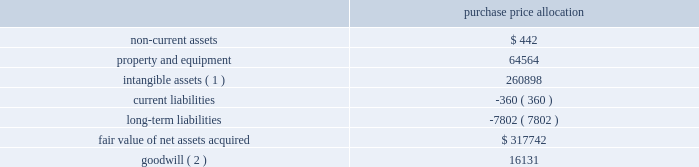American tower corporation and subsidiaries notes to consolidated financial statements u.s .
Acquisitions 2014during the year ended december 31 , 2010 , the company acquired 548 towers through multiple acquisitions in the united states for an aggregate purchase price of $ 329.3 million and contingent consideration of approximately $ 4.6 million .
The acquisition of these towers is consistent with the company 2019s strategy to expand in selected geographic areas and have been accounted for as business combinations .
The table summarizes the preliminary allocation of the aggregate purchase consideration paid and the amounts of assets acquired and liabilities assumed based on the estimated fair value of the acquired assets and assumed liabilities at the date of acquisition ( in thousands ) : purchase price allocation .
( 1 ) consists of customer relationships of approximately $ 205.4 million and network location intangibles of approximately $ 55.5 million .
The customer relationships and network location intangibles are being amortized on a straight-line basis over a period of 20 years .
( 2 ) goodwill is expected to be deductible for income tax purposes .
The goodwill was allocated to the domestic rental and management segment .
The allocation of the purchase price will be finalized upon completion of analyses of the fair value of the assets acquired and liabilities assumed .
South africa acquisition 2014on november 4 , 2010 , the company entered into a definitive agreement with cell c ( pty ) limited to purchase up to approximately 1400 existing towers , and up to 1800 additional towers that either are under construction or will be constructed , for an aggregate purchase price of up to approximately $ 430 million .
The company anticipates closing the purchase of up to 1400 existing towers during 2011 , subject to customary closing conditions .
Other transactions coltel transaction 2014on september 3 , 2010 , the company entered into a definitive agreement to purchase the exclusive use rights for towers in colombia from colombia telecomunicaciones s.a .
E.s.p .
( 201ccoltel 201d ) until 2023 , when ownership of the towers will transfer to the company at no additional cost .
Pursuant to that agreement , the company completed the purchase of exclusive use rights for 508 towers for an aggregate purchase price of $ 86.8 million during the year ended december 31 , 2010 .
The company expects to complete the purchase of the exclusive use rights for an additional 180 towers by the end of 2011 , subject to customary closing conditions .
The transaction has been accounted for as a capital lease , with the aggregated purchase price being allocated to property and equipment and non-current assets .
Joint venture with mtn group 2014on december 6 , 2010 , the company entered into a definitive agreement with mtn group limited ( 201cmtn group 201d ) to establish a joint venture in ghana ( 201ctowerco ghana 201d ) .
Towerco ghana , which will be managed by the company , will be owned by a holding company of which a wholly owned american tower subsidiary will hold a 51% ( 51 % ) share and a wholly owned mtn group subsidiary ( 201cmtn ghana 201d ) will hold a 49% ( 49 % ) share .
The transaction involves the sale of up to 1876 of mtn ghana 2019s existing sites to .
Of the total fair value of net assets acquired what was the percent applicable to the equipment? 
Computations: (64564 / 317742)
Answer: 0.2032. American tower corporation and subsidiaries notes to consolidated financial statements u.s .
Acquisitions 2014during the year ended december 31 , 2010 , the company acquired 548 towers through multiple acquisitions in the united states for an aggregate purchase price of $ 329.3 million and contingent consideration of approximately $ 4.6 million .
The acquisition of these towers is consistent with the company 2019s strategy to expand in selected geographic areas and have been accounted for as business combinations .
The table summarizes the preliminary allocation of the aggregate purchase consideration paid and the amounts of assets acquired and liabilities assumed based on the estimated fair value of the acquired assets and assumed liabilities at the date of acquisition ( in thousands ) : purchase price allocation .
( 1 ) consists of customer relationships of approximately $ 205.4 million and network location intangibles of approximately $ 55.5 million .
The customer relationships and network location intangibles are being amortized on a straight-line basis over a period of 20 years .
( 2 ) goodwill is expected to be deductible for income tax purposes .
The goodwill was allocated to the domestic rental and management segment .
The allocation of the purchase price will be finalized upon completion of analyses of the fair value of the assets acquired and liabilities assumed .
South africa acquisition 2014on november 4 , 2010 , the company entered into a definitive agreement with cell c ( pty ) limited to purchase up to approximately 1400 existing towers , and up to 1800 additional towers that either are under construction or will be constructed , for an aggregate purchase price of up to approximately $ 430 million .
The company anticipates closing the purchase of up to 1400 existing towers during 2011 , subject to customary closing conditions .
Other transactions coltel transaction 2014on september 3 , 2010 , the company entered into a definitive agreement to purchase the exclusive use rights for towers in colombia from colombia telecomunicaciones s.a .
E.s.p .
( 201ccoltel 201d ) until 2023 , when ownership of the towers will transfer to the company at no additional cost .
Pursuant to that agreement , the company completed the purchase of exclusive use rights for 508 towers for an aggregate purchase price of $ 86.8 million during the year ended december 31 , 2010 .
The company expects to complete the purchase of the exclusive use rights for an additional 180 towers by the end of 2011 , subject to customary closing conditions .
The transaction has been accounted for as a capital lease , with the aggregated purchase price being allocated to property and equipment and non-current assets .
Joint venture with mtn group 2014on december 6 , 2010 , the company entered into a definitive agreement with mtn group limited ( 201cmtn group 201d ) to establish a joint venture in ghana ( 201ctowerco ghana 201d ) .
Towerco ghana , which will be managed by the company , will be owned by a holding company of which a wholly owned american tower subsidiary will hold a 51% ( 51 % ) share and a wholly owned mtn group subsidiary ( 201cmtn ghana 201d ) will hold a 49% ( 49 % ) share .
The transaction involves the sale of up to 1876 of mtn ghana 2019s existing sites to .
Based on the agreement what was the average price completed the purchase of exclusive use rights to the towers in 2010 in millions? 
Computations: (86.8 / 508)
Answer: 0.17087. American tower corporation and subsidiaries notes to consolidated financial statements u.s .
Acquisitions 2014during the year ended december 31 , 2010 , the company acquired 548 towers through multiple acquisitions in the united states for an aggregate purchase price of $ 329.3 million and contingent consideration of approximately $ 4.6 million .
The acquisition of these towers is consistent with the company 2019s strategy to expand in selected geographic areas and have been accounted for as business combinations .
The table summarizes the preliminary allocation of the aggregate purchase consideration paid and the amounts of assets acquired and liabilities assumed based on the estimated fair value of the acquired assets and assumed liabilities at the date of acquisition ( in thousands ) : purchase price allocation .
( 1 ) consists of customer relationships of approximately $ 205.4 million and network location intangibles of approximately $ 55.5 million .
The customer relationships and network location intangibles are being amortized on a straight-line basis over a period of 20 years .
( 2 ) goodwill is expected to be deductible for income tax purposes .
The goodwill was allocated to the domestic rental and management segment .
The allocation of the purchase price will be finalized upon completion of analyses of the fair value of the assets acquired and liabilities assumed .
South africa acquisition 2014on november 4 , 2010 , the company entered into a definitive agreement with cell c ( pty ) limited to purchase up to approximately 1400 existing towers , and up to 1800 additional towers that either are under construction or will be constructed , for an aggregate purchase price of up to approximately $ 430 million .
The company anticipates closing the purchase of up to 1400 existing towers during 2011 , subject to customary closing conditions .
Other transactions coltel transaction 2014on september 3 , 2010 , the company entered into a definitive agreement to purchase the exclusive use rights for towers in colombia from colombia telecomunicaciones s.a .
E.s.p .
( 201ccoltel 201d ) until 2023 , when ownership of the towers will transfer to the company at no additional cost .
Pursuant to that agreement , the company completed the purchase of exclusive use rights for 508 towers for an aggregate purchase price of $ 86.8 million during the year ended december 31 , 2010 .
The company expects to complete the purchase of the exclusive use rights for an additional 180 towers by the end of 2011 , subject to customary closing conditions .
The transaction has been accounted for as a capital lease , with the aggregated purchase price being allocated to property and equipment and non-current assets .
Joint venture with mtn group 2014on december 6 , 2010 , the company entered into a definitive agreement with mtn group limited ( 201cmtn group 201d ) to establish a joint venture in ghana ( 201ctowerco ghana 201d ) .
Towerco ghana , which will be managed by the company , will be owned by a holding company of which a wholly owned american tower subsidiary will hold a 51% ( 51 % ) share and a wholly owned mtn group subsidiary ( 201cmtn ghana 201d ) will hold a 49% ( 49 % ) share .
The transaction involves the sale of up to 1876 of mtn ghana 2019s existing sites to .
What is the annual amortization expense related to customer relationships and network location intangibles , in millions? 
Computations: ((205.4 + 55.5) / 20)
Answer: 13.045. 